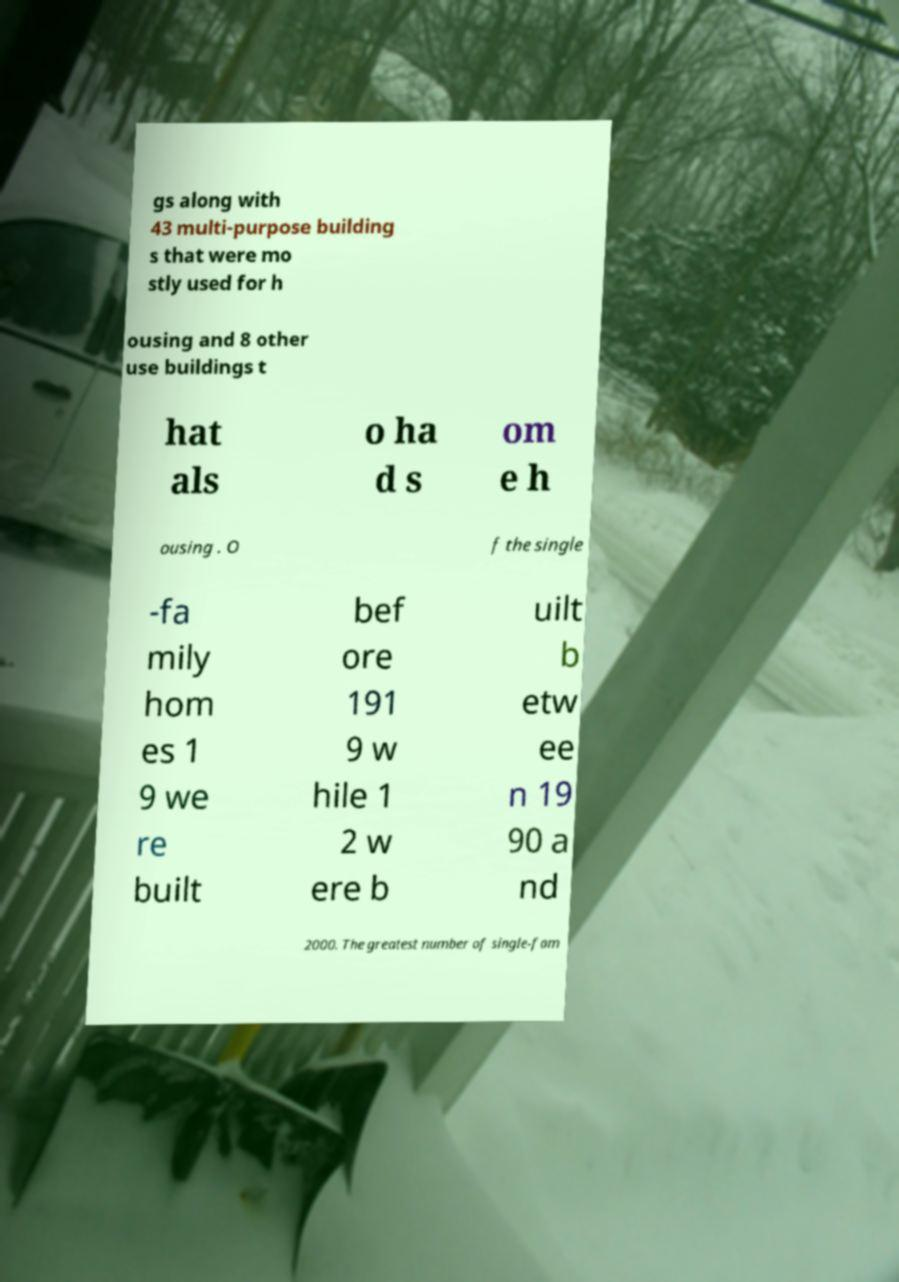I need the written content from this picture converted into text. Can you do that? gs along with 43 multi-purpose building s that were mo stly used for h ousing and 8 other use buildings t hat als o ha d s om e h ousing . O f the single -fa mily hom es 1 9 we re built bef ore 191 9 w hile 1 2 w ere b uilt b etw ee n 19 90 a nd 2000. The greatest number of single-fam 